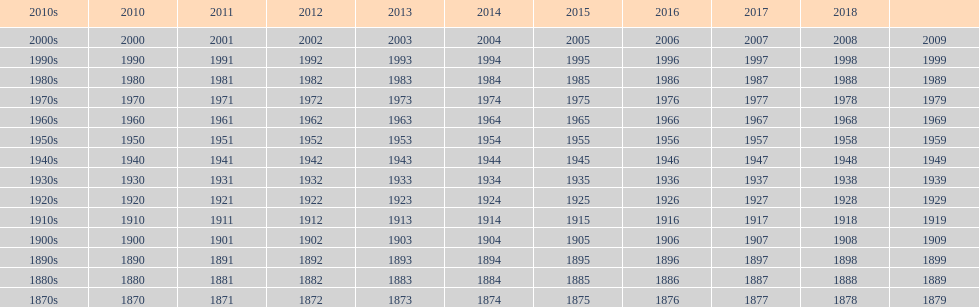When was the earliest film in history released? 1870. 